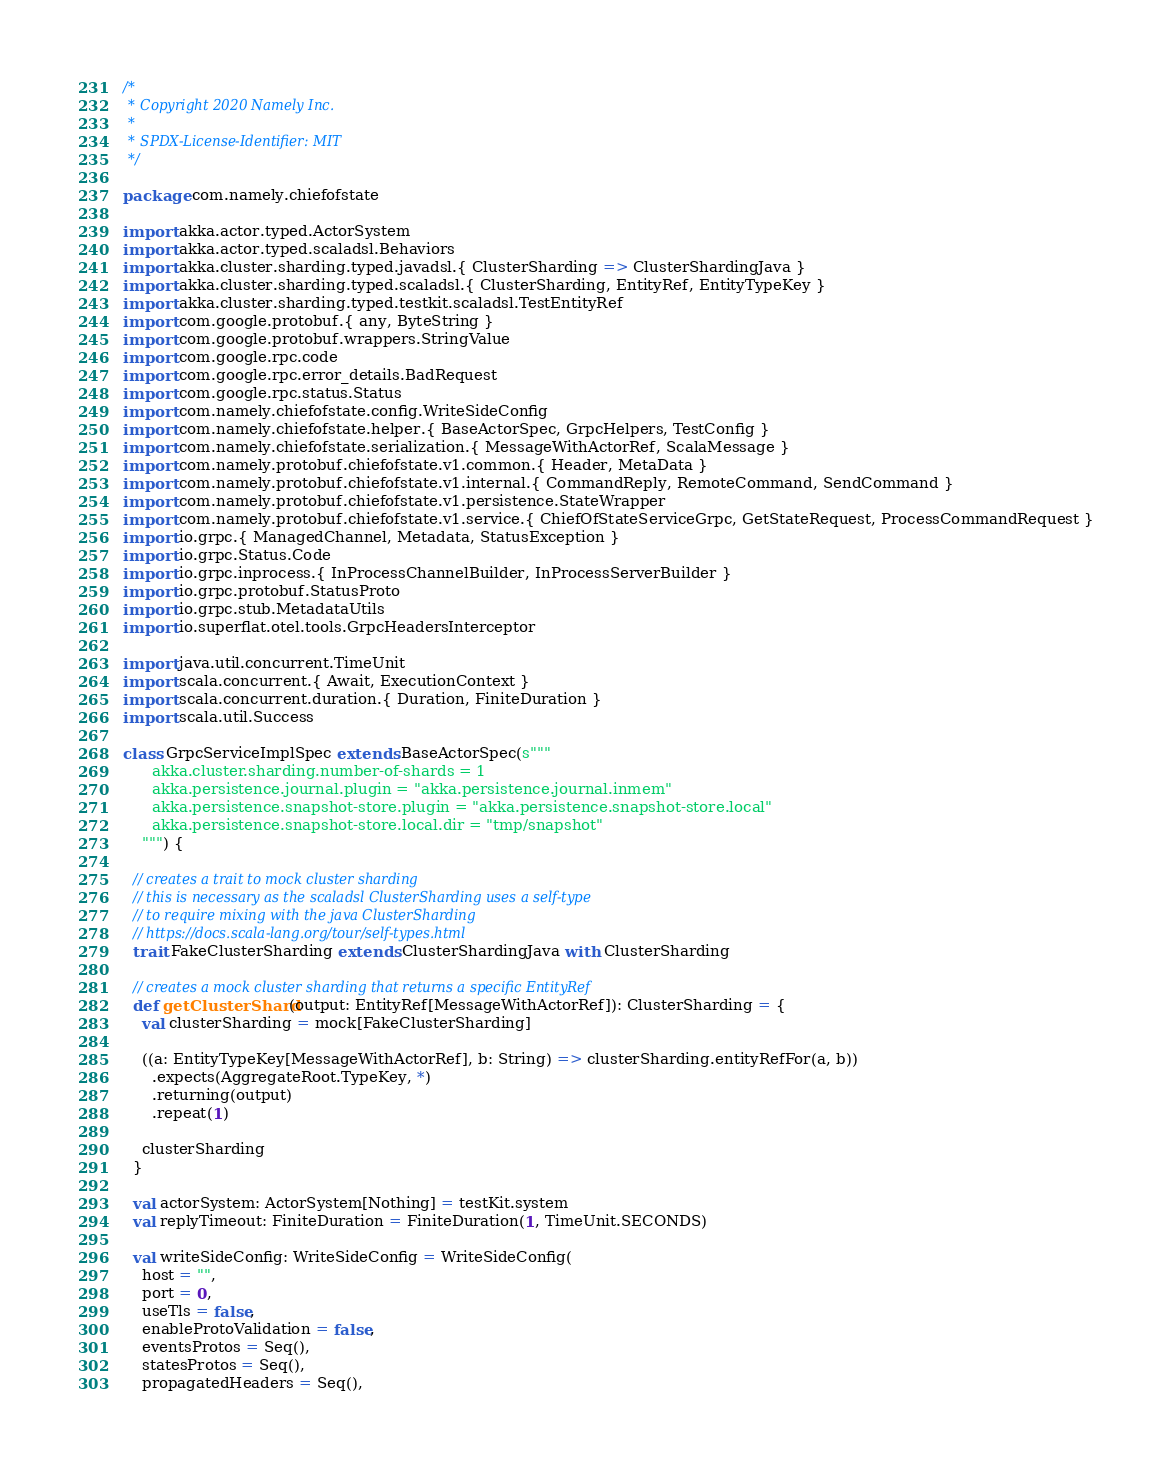<code> <loc_0><loc_0><loc_500><loc_500><_Scala_>/*
 * Copyright 2020 Namely Inc.
 *
 * SPDX-License-Identifier: MIT
 */

package com.namely.chiefofstate

import akka.actor.typed.ActorSystem
import akka.actor.typed.scaladsl.Behaviors
import akka.cluster.sharding.typed.javadsl.{ ClusterSharding => ClusterShardingJava }
import akka.cluster.sharding.typed.scaladsl.{ ClusterSharding, EntityRef, EntityTypeKey }
import akka.cluster.sharding.typed.testkit.scaladsl.TestEntityRef
import com.google.protobuf.{ any, ByteString }
import com.google.protobuf.wrappers.StringValue
import com.google.rpc.code
import com.google.rpc.error_details.BadRequest
import com.google.rpc.status.Status
import com.namely.chiefofstate.config.WriteSideConfig
import com.namely.chiefofstate.helper.{ BaseActorSpec, GrpcHelpers, TestConfig }
import com.namely.chiefofstate.serialization.{ MessageWithActorRef, ScalaMessage }
import com.namely.protobuf.chiefofstate.v1.common.{ Header, MetaData }
import com.namely.protobuf.chiefofstate.v1.internal.{ CommandReply, RemoteCommand, SendCommand }
import com.namely.protobuf.chiefofstate.v1.persistence.StateWrapper
import com.namely.protobuf.chiefofstate.v1.service.{ ChiefOfStateServiceGrpc, GetStateRequest, ProcessCommandRequest }
import io.grpc.{ ManagedChannel, Metadata, StatusException }
import io.grpc.Status.Code
import io.grpc.inprocess.{ InProcessChannelBuilder, InProcessServerBuilder }
import io.grpc.protobuf.StatusProto
import io.grpc.stub.MetadataUtils
import io.superflat.otel.tools.GrpcHeadersInterceptor

import java.util.concurrent.TimeUnit
import scala.concurrent.{ Await, ExecutionContext }
import scala.concurrent.duration.{ Duration, FiniteDuration }
import scala.util.Success

class GrpcServiceImplSpec extends BaseActorSpec(s"""
      akka.cluster.sharding.number-of-shards = 1
      akka.persistence.journal.plugin = "akka.persistence.journal.inmem"
      akka.persistence.snapshot-store.plugin = "akka.persistence.snapshot-store.local"
      akka.persistence.snapshot-store.local.dir = "tmp/snapshot"
    """) {

  // creates a trait to mock cluster sharding
  // this is necessary as the scaladsl ClusterSharding uses a self-type
  // to require mixing with the java ClusterSharding
  // https://docs.scala-lang.org/tour/self-types.html
  trait FakeClusterSharding extends ClusterShardingJava with ClusterSharding

  // creates a mock cluster sharding that returns a specific EntityRef
  def getClusterShard(output: EntityRef[MessageWithActorRef]): ClusterSharding = {
    val clusterSharding = mock[FakeClusterSharding]

    ((a: EntityTypeKey[MessageWithActorRef], b: String) => clusterSharding.entityRefFor(a, b))
      .expects(AggregateRoot.TypeKey, *)
      .returning(output)
      .repeat(1)

    clusterSharding
  }

  val actorSystem: ActorSystem[Nothing] = testKit.system
  val replyTimeout: FiniteDuration = FiniteDuration(1, TimeUnit.SECONDS)

  val writeSideConfig: WriteSideConfig = WriteSideConfig(
    host = "",
    port = 0,
    useTls = false,
    enableProtoValidation = false,
    eventsProtos = Seq(),
    statesProtos = Seq(),
    propagatedHeaders = Seq(),</code> 